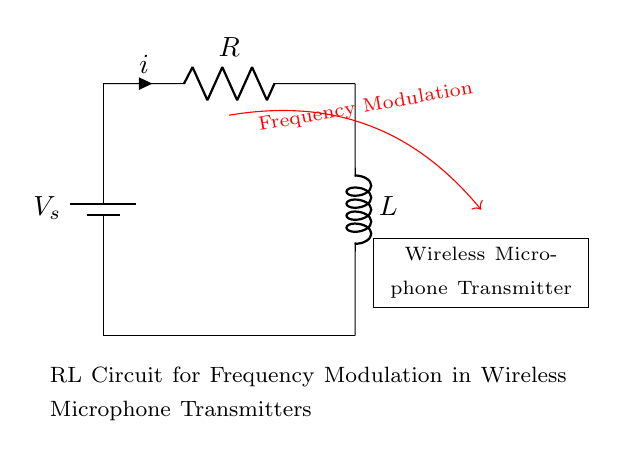What components are present in this circuit? The circuit consists of a battery, a resistor, and an inductor. These components are essential for its function as an RL circuit.
Answer: Battery, resistor, inductor What is the purpose of the red arrow in this circuit? The red arrow indicates the direction of the frequency modulation signal related to the wireless microphone transmitter, showing how it interfaces with the circuit.
Answer: Frequency modulation What is the value of the current indicated in the circuit? The value of the current is represented by the current symbol next to the resistor, which is marked as i, but the exact numerical value is not given in this circuit visualization.
Answer: i What does the symbol next to the resistor represent? The symbol next to the resistor indicates the current flowing through it, labeled as i with an arrow denoting its direction.
Answer: i How do the resistor and inductor interact in this circuit? In an RL circuit, the resistor limits the current and dissipates energy as heat, while the inductor stores energy in a magnetic field and reacts to changes in current. Their interaction is crucial in controlling the frequency modulation.
Answer: Limit current, store energy What effect does the inductor have on the circuit's frequency response? The inductor introduces reactance which varies with frequency, causing a phase shift and affecting the circuit's resonance characteristics, thus influencing how the circuit modulates audio signals for transmission.
Answer: Influences resonance What role does this RL circuit play in wireless microphone transmitters? This RL circuit is used for modulating the audio signal into a radio frequency for wireless transmission, allowing the microphone's sound to be wirelessly relayed.
Answer: Modulates audio signals 